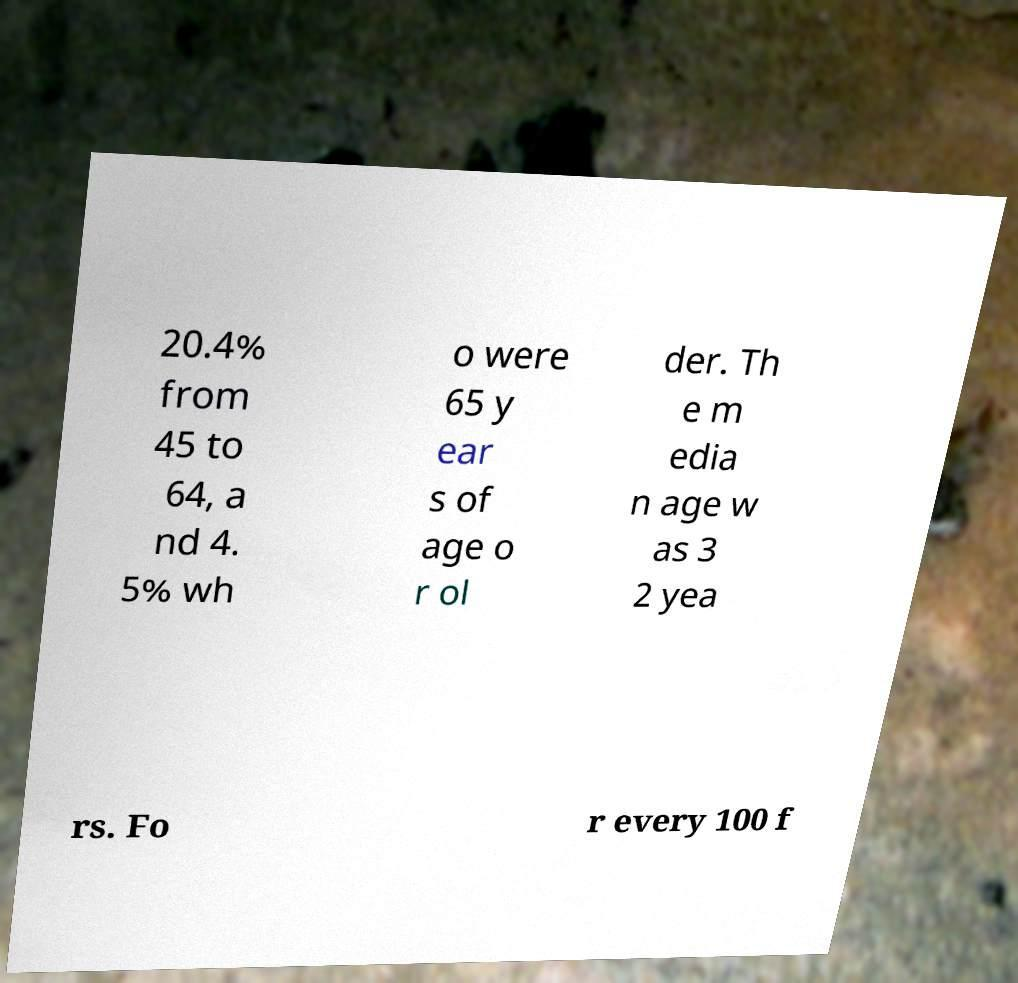What messages or text are displayed in this image? I need them in a readable, typed format. 20.4% from 45 to 64, a nd 4. 5% wh o were 65 y ear s of age o r ol der. Th e m edia n age w as 3 2 yea rs. Fo r every 100 f 